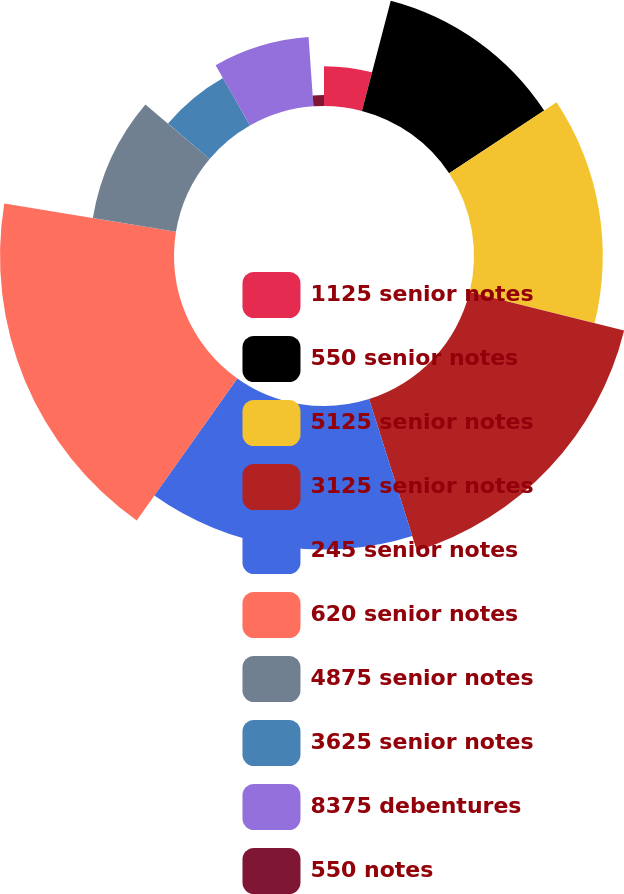<chart> <loc_0><loc_0><loc_500><loc_500><pie_chart><fcel>1125 senior notes<fcel>550 senior notes<fcel>5125 senior notes<fcel>3125 senior notes<fcel>245 senior notes<fcel>620 senior notes<fcel>4875 senior notes<fcel>3625 senior notes<fcel>8375 debentures<fcel>550 notes<nl><fcel>4.07%<fcel>11.64%<fcel>13.16%<fcel>16.27%<fcel>14.67%<fcel>17.78%<fcel>8.61%<fcel>5.58%<fcel>7.1%<fcel>1.12%<nl></chart> 